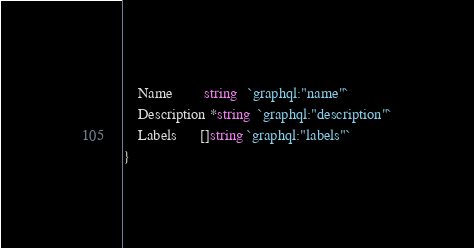Convert code to text. <code><loc_0><loc_0><loc_500><loc_500><_Go_>	Name        string   `graphql:"name"`
	Description *string  `graphql:"description"`
	Labels      []string `graphql:"labels"`
}
</code> 